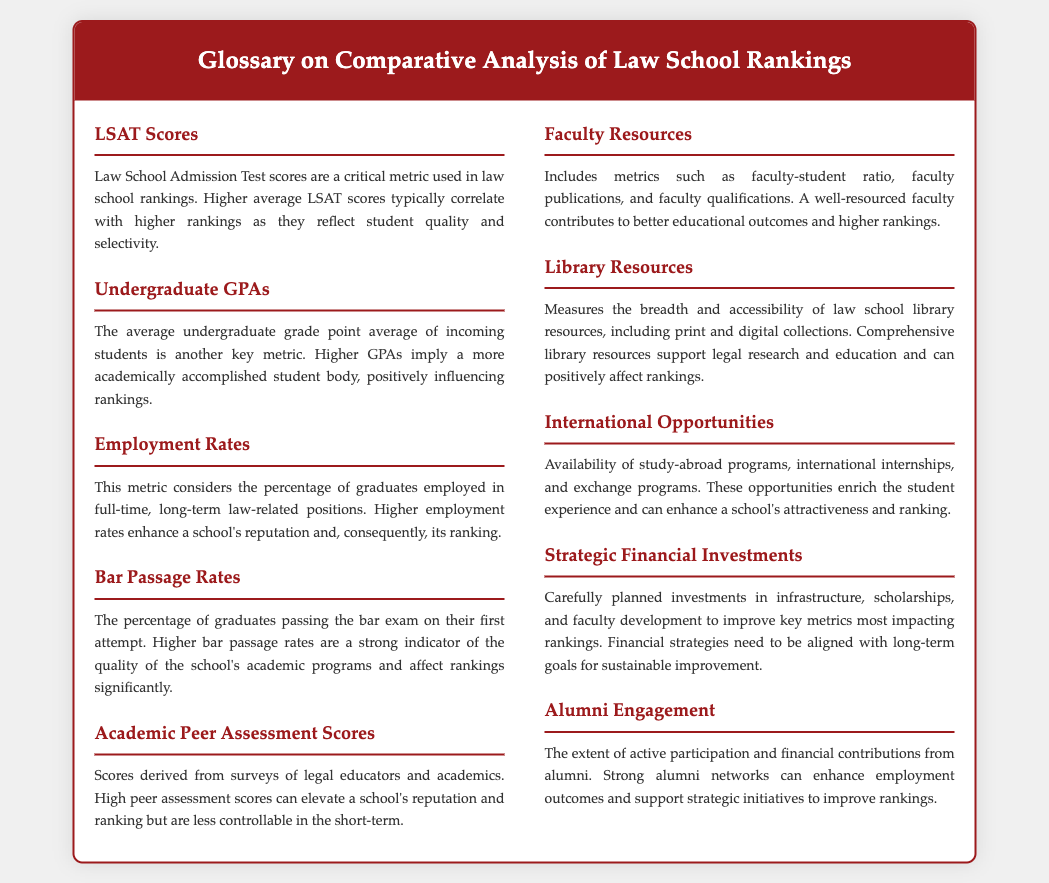What metric reflects student quality and selectivity? The LSAT Scores are used to reflect the quality of incoming students and their selectivity, which is critical in law school rankings.
Answer: LSAT Scores What does a higher average GPA signify? Higher undergraduate GPAs imply a more academically accomplished student body, which positively influences rankings.
Answer: Higher GPAs What percentage is considered important for employment rates? The employment rates metric considers the percentage of graduates employed in full-time, long-term law-related positions, affecting rankings.
Answer: Percentage What is a strong indicator of academic program quality? Higher bar passage rates indicate the quality of a school's academic programs and impact rankings significantly.
Answer: Bar passage rates What contributes to better educational outcomes? Faculty resources, including faculty-student ratio and qualifications, contribute to better educational outcomes and higher rankings.
Answer: Faculty resources Which metric is derived from legal educators' surveys? Academic Peer Assessment Scores are derived from surveys of legal educators and can elevate a school's reputation and ranking.
Answer: Academic Peer Assessment Scores What measures the accessibility of law school library resources? Library Resources measure the breadth and accessibility of both print and digital collections available to students.
Answer: Library Resources How can financial strategies improve rankings? Strategic Financial Investments in infrastructure and faculty development are essential for improving key metrics impacting rankings.
Answer: Strategic Financial Investments What enhances alumni engagement? The extent of active participation and financial contributions from alumni can significantly improve school rankings.
Answer: Active participation and contributions 